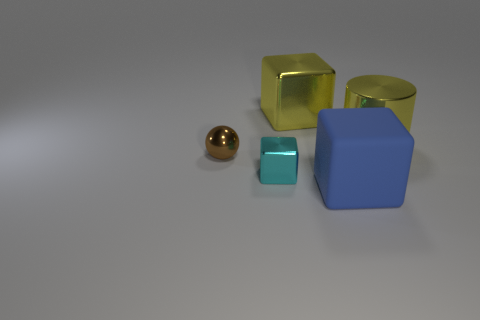How does the size of the golden sphere compare to the other objects? The golden sphere is smaller than the cubes but larger than the small cyan object, which suggests a medium size relative to the other items. 